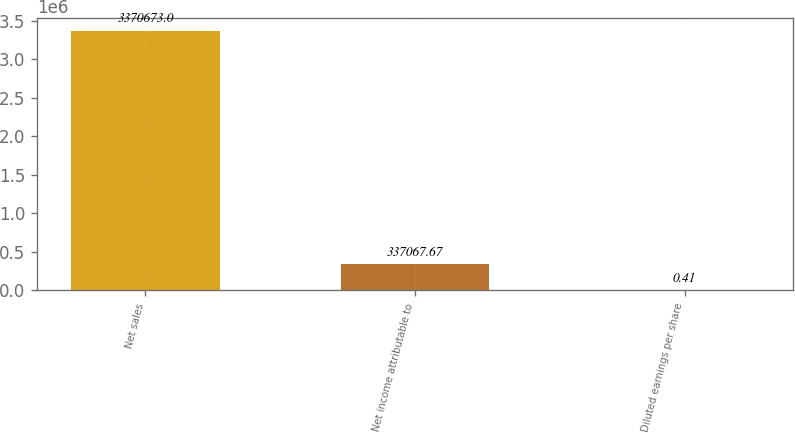<chart> <loc_0><loc_0><loc_500><loc_500><bar_chart><fcel>Net sales<fcel>Net income attributable to<fcel>Diluted earnings per share<nl><fcel>3.37067e+06<fcel>337068<fcel>0.41<nl></chart> 